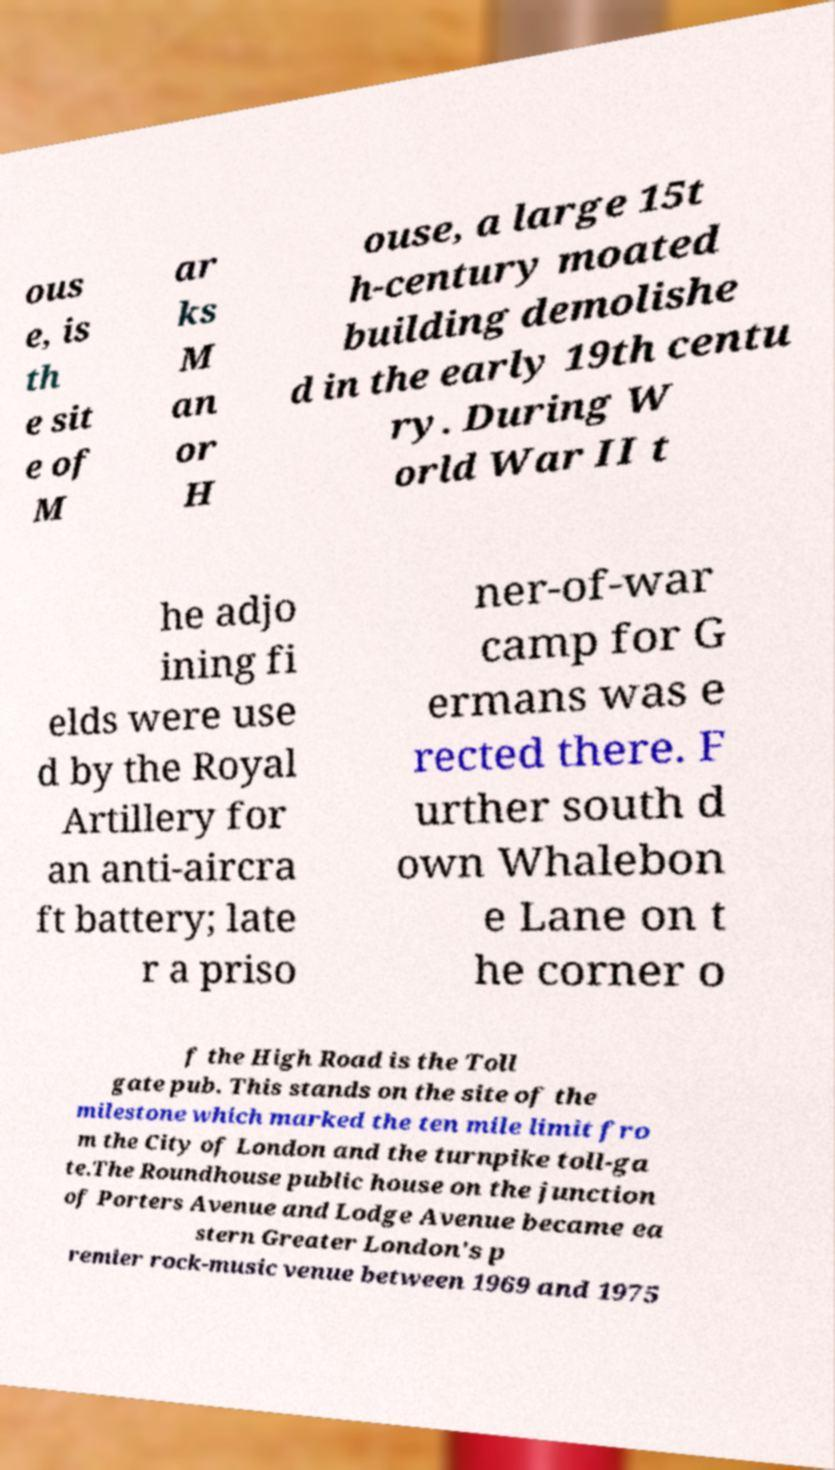Could you assist in decoding the text presented in this image and type it out clearly? ous e, is th e sit e of M ar ks M an or H ouse, a large 15t h-century moated building demolishe d in the early 19th centu ry. During W orld War II t he adjo ining fi elds were use d by the Royal Artillery for an anti-aircra ft battery; late r a priso ner-of-war camp for G ermans was e rected there. F urther south d own Whalebon e Lane on t he corner o f the High Road is the Toll gate pub. This stands on the site of the milestone which marked the ten mile limit fro m the City of London and the turnpike toll-ga te.The Roundhouse public house on the junction of Porters Avenue and Lodge Avenue became ea stern Greater London's p remier rock-music venue between 1969 and 1975 